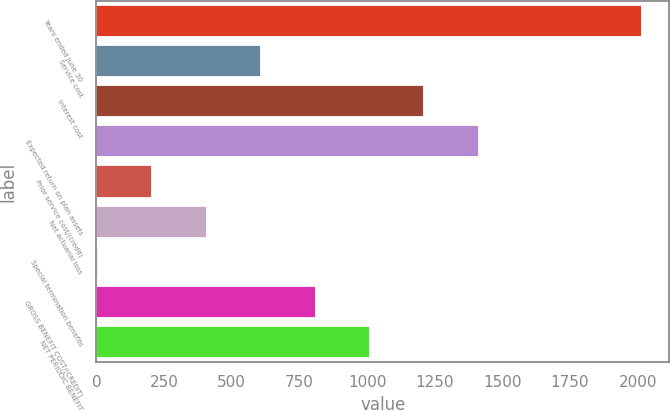Convert chart to OTSL. <chart><loc_0><loc_0><loc_500><loc_500><bar_chart><fcel>Years ended June 30<fcel>Service cost<fcel>Interest cost<fcel>Expected return on plan assets<fcel>Prior service cost/(credit)<fcel>Net actuarial loss<fcel>Special termination benefits<fcel>GROSS BENEFIT COST/(CREDIT)<fcel>NET PERIODIC BENEFIT<nl><fcel>2016<fcel>609<fcel>1212<fcel>1413<fcel>207<fcel>408<fcel>6<fcel>810<fcel>1011<nl></chart> 